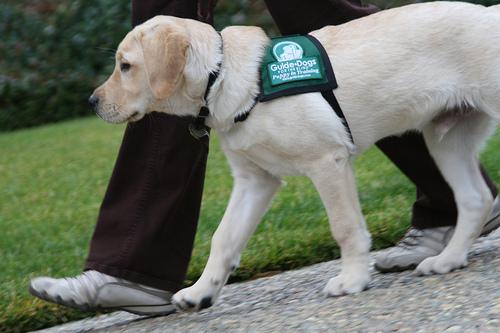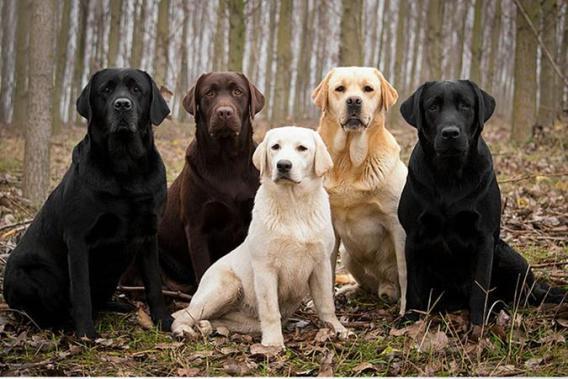The first image is the image on the left, the second image is the image on the right. For the images displayed, is the sentence "There are six dogs in total." factually correct? Answer yes or no. Yes. The first image is the image on the left, the second image is the image on the right. Examine the images to the left and right. Is the description "A person's legs are visible behind at least one dog." accurate? Answer yes or no. Yes. 